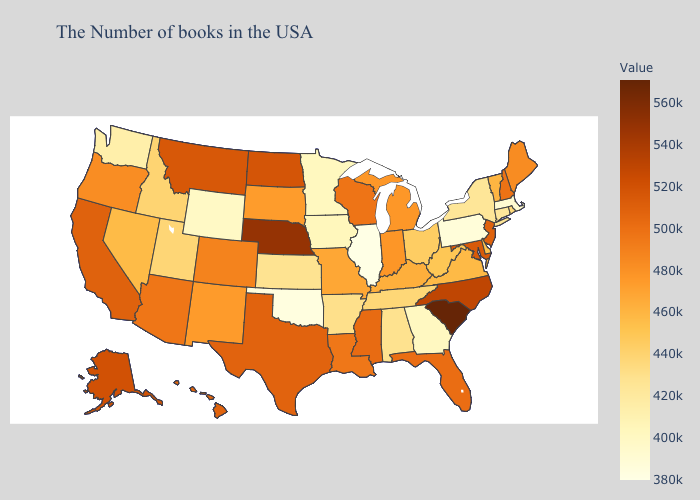Does New Jersey have the highest value in the Northeast?
Answer briefly. Yes. Which states hav the highest value in the South?
Be succinct. South Carolina. Which states have the highest value in the USA?
Keep it brief. South Carolina. 